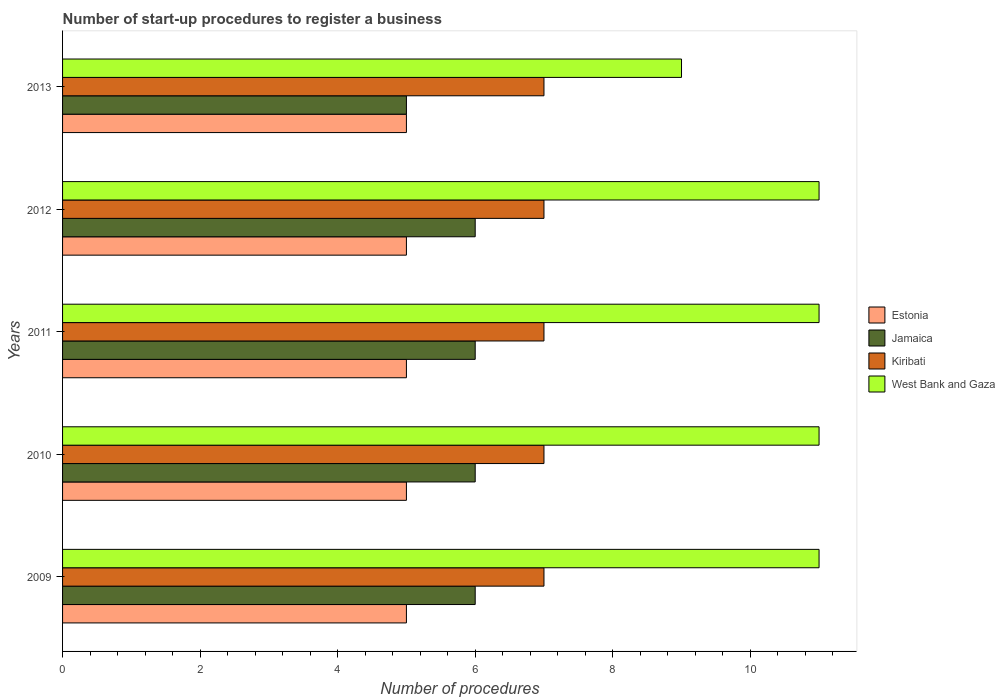How many different coloured bars are there?
Your answer should be compact. 4. How many bars are there on the 5th tick from the top?
Your answer should be very brief. 4. How many bars are there on the 5th tick from the bottom?
Ensure brevity in your answer.  4. What is the number of procedures required to register a business in Kiribati in 2013?
Keep it short and to the point. 7. Across all years, what is the maximum number of procedures required to register a business in Estonia?
Ensure brevity in your answer.  5. Across all years, what is the minimum number of procedures required to register a business in Jamaica?
Ensure brevity in your answer.  5. In which year was the number of procedures required to register a business in West Bank and Gaza maximum?
Your response must be concise. 2009. What is the total number of procedures required to register a business in Kiribati in the graph?
Provide a short and direct response. 35. What is the difference between the number of procedures required to register a business in West Bank and Gaza in 2009 and that in 2013?
Keep it short and to the point. 2. What is the difference between the number of procedures required to register a business in Kiribati in 2010 and the number of procedures required to register a business in West Bank and Gaza in 2012?
Provide a short and direct response. -4. What is the average number of procedures required to register a business in Jamaica per year?
Your answer should be very brief. 5.8. In how many years, is the number of procedures required to register a business in West Bank and Gaza greater than 4 ?
Your answer should be very brief. 5. What is the ratio of the number of procedures required to register a business in Jamaica in 2011 to that in 2012?
Make the answer very short. 1. Is the number of procedures required to register a business in West Bank and Gaza in 2012 less than that in 2013?
Keep it short and to the point. No. Is the difference between the number of procedures required to register a business in Estonia in 2010 and 2011 greater than the difference between the number of procedures required to register a business in Jamaica in 2010 and 2011?
Keep it short and to the point. No. What is the difference between the highest and the second highest number of procedures required to register a business in Jamaica?
Provide a succinct answer. 0. What is the difference between the highest and the lowest number of procedures required to register a business in Estonia?
Keep it short and to the point. 0. In how many years, is the number of procedures required to register a business in Jamaica greater than the average number of procedures required to register a business in Jamaica taken over all years?
Your answer should be very brief. 4. Is the sum of the number of procedures required to register a business in Kiribati in 2010 and 2013 greater than the maximum number of procedures required to register a business in Jamaica across all years?
Provide a short and direct response. Yes. Is it the case that in every year, the sum of the number of procedures required to register a business in Kiribati and number of procedures required to register a business in West Bank and Gaza is greater than the sum of number of procedures required to register a business in Jamaica and number of procedures required to register a business in Estonia?
Keep it short and to the point. Yes. What does the 1st bar from the top in 2010 represents?
Offer a terse response. West Bank and Gaza. What does the 3rd bar from the bottom in 2011 represents?
Keep it short and to the point. Kiribati. Is it the case that in every year, the sum of the number of procedures required to register a business in Jamaica and number of procedures required to register a business in West Bank and Gaza is greater than the number of procedures required to register a business in Estonia?
Offer a terse response. Yes. Are the values on the major ticks of X-axis written in scientific E-notation?
Your answer should be compact. No. Does the graph contain grids?
Give a very brief answer. No. How many legend labels are there?
Your answer should be compact. 4. What is the title of the graph?
Provide a succinct answer. Number of start-up procedures to register a business. Does "Syrian Arab Republic" appear as one of the legend labels in the graph?
Your response must be concise. No. What is the label or title of the X-axis?
Your response must be concise. Number of procedures. What is the Number of procedures of Estonia in 2009?
Your answer should be compact. 5. What is the Number of procedures in Jamaica in 2009?
Ensure brevity in your answer.  6. What is the Number of procedures in Kiribati in 2009?
Give a very brief answer. 7. What is the Number of procedures of Kiribati in 2010?
Provide a short and direct response. 7. What is the Number of procedures of Estonia in 2011?
Your response must be concise. 5. What is the Number of procedures of Kiribati in 2011?
Keep it short and to the point. 7. What is the Number of procedures of West Bank and Gaza in 2011?
Offer a very short reply. 11. What is the Number of procedures of Estonia in 2012?
Your answer should be very brief. 5. What is the Number of procedures of Kiribati in 2012?
Ensure brevity in your answer.  7. What is the Number of procedures in Estonia in 2013?
Provide a succinct answer. 5. What is the Number of procedures in Jamaica in 2013?
Make the answer very short. 5. What is the Number of procedures in West Bank and Gaza in 2013?
Offer a terse response. 9. Across all years, what is the minimum Number of procedures of Jamaica?
Give a very brief answer. 5. What is the total Number of procedures of Estonia in the graph?
Offer a terse response. 25. What is the total Number of procedures in Jamaica in the graph?
Give a very brief answer. 29. What is the total Number of procedures of West Bank and Gaza in the graph?
Keep it short and to the point. 53. What is the difference between the Number of procedures in Estonia in 2009 and that in 2010?
Your answer should be compact. 0. What is the difference between the Number of procedures of Jamaica in 2009 and that in 2010?
Your answer should be very brief. 0. What is the difference between the Number of procedures in West Bank and Gaza in 2009 and that in 2010?
Your answer should be compact. 0. What is the difference between the Number of procedures in West Bank and Gaza in 2009 and that in 2011?
Your answer should be very brief. 0. What is the difference between the Number of procedures of Estonia in 2009 and that in 2012?
Ensure brevity in your answer.  0. What is the difference between the Number of procedures of West Bank and Gaza in 2009 and that in 2012?
Your answer should be compact. 0. What is the difference between the Number of procedures in Estonia in 2009 and that in 2013?
Your answer should be very brief. 0. What is the difference between the Number of procedures of West Bank and Gaza in 2010 and that in 2011?
Offer a very short reply. 0. What is the difference between the Number of procedures of Kiribati in 2010 and that in 2012?
Provide a short and direct response. 0. What is the difference between the Number of procedures in West Bank and Gaza in 2010 and that in 2012?
Your answer should be very brief. 0. What is the difference between the Number of procedures in Jamaica in 2011 and that in 2012?
Give a very brief answer. 0. What is the difference between the Number of procedures in West Bank and Gaza in 2011 and that in 2012?
Your response must be concise. 0. What is the difference between the Number of procedures of Jamaica in 2011 and that in 2013?
Keep it short and to the point. 1. What is the difference between the Number of procedures in Kiribati in 2011 and that in 2013?
Keep it short and to the point. 0. What is the difference between the Number of procedures in Estonia in 2009 and the Number of procedures in Jamaica in 2010?
Give a very brief answer. -1. What is the difference between the Number of procedures of Estonia in 2009 and the Number of procedures of Kiribati in 2011?
Offer a terse response. -2. What is the difference between the Number of procedures of Estonia in 2009 and the Number of procedures of West Bank and Gaza in 2011?
Keep it short and to the point. -6. What is the difference between the Number of procedures of Jamaica in 2009 and the Number of procedures of West Bank and Gaza in 2011?
Offer a terse response. -5. What is the difference between the Number of procedures in Estonia in 2009 and the Number of procedures in Jamaica in 2012?
Your answer should be compact. -1. What is the difference between the Number of procedures in Estonia in 2009 and the Number of procedures in Kiribati in 2012?
Your answer should be compact. -2. What is the difference between the Number of procedures in Estonia in 2009 and the Number of procedures in West Bank and Gaza in 2012?
Give a very brief answer. -6. What is the difference between the Number of procedures in Kiribati in 2009 and the Number of procedures in West Bank and Gaza in 2012?
Provide a succinct answer. -4. What is the difference between the Number of procedures of Estonia in 2009 and the Number of procedures of Jamaica in 2013?
Your answer should be compact. 0. What is the difference between the Number of procedures in Jamaica in 2009 and the Number of procedures in Kiribati in 2013?
Ensure brevity in your answer.  -1. What is the difference between the Number of procedures of Kiribati in 2009 and the Number of procedures of West Bank and Gaza in 2013?
Make the answer very short. -2. What is the difference between the Number of procedures of Estonia in 2010 and the Number of procedures of Jamaica in 2011?
Provide a succinct answer. -1. What is the difference between the Number of procedures in Estonia in 2010 and the Number of procedures in Kiribati in 2011?
Offer a very short reply. -2. What is the difference between the Number of procedures in Estonia in 2010 and the Number of procedures in West Bank and Gaza in 2011?
Your answer should be very brief. -6. What is the difference between the Number of procedures in Jamaica in 2010 and the Number of procedures in Kiribati in 2011?
Make the answer very short. -1. What is the difference between the Number of procedures in Kiribati in 2010 and the Number of procedures in West Bank and Gaza in 2011?
Provide a succinct answer. -4. What is the difference between the Number of procedures in Estonia in 2010 and the Number of procedures in West Bank and Gaza in 2012?
Your answer should be compact. -6. What is the difference between the Number of procedures of Jamaica in 2010 and the Number of procedures of Kiribati in 2012?
Offer a terse response. -1. What is the difference between the Number of procedures in Estonia in 2010 and the Number of procedures in Jamaica in 2013?
Give a very brief answer. 0. What is the difference between the Number of procedures of Estonia in 2011 and the Number of procedures of Jamaica in 2012?
Offer a very short reply. -1. What is the difference between the Number of procedures in Estonia in 2011 and the Number of procedures in West Bank and Gaza in 2012?
Offer a terse response. -6. What is the difference between the Number of procedures in Kiribati in 2011 and the Number of procedures in West Bank and Gaza in 2012?
Your answer should be very brief. -4. What is the difference between the Number of procedures of Estonia in 2011 and the Number of procedures of Jamaica in 2013?
Provide a short and direct response. 0. What is the difference between the Number of procedures of Estonia in 2011 and the Number of procedures of West Bank and Gaza in 2013?
Your answer should be very brief. -4. What is the difference between the Number of procedures in Jamaica in 2011 and the Number of procedures in Kiribati in 2013?
Your answer should be very brief. -1. What is the difference between the Number of procedures in Estonia in 2012 and the Number of procedures in Jamaica in 2013?
Your response must be concise. 0. What is the difference between the Number of procedures of Estonia in 2012 and the Number of procedures of Kiribati in 2013?
Your answer should be compact. -2. What is the difference between the Number of procedures in Estonia in 2012 and the Number of procedures in West Bank and Gaza in 2013?
Provide a short and direct response. -4. What is the difference between the Number of procedures in Jamaica in 2012 and the Number of procedures in Kiribati in 2013?
Provide a succinct answer. -1. What is the difference between the Number of procedures of Jamaica in 2012 and the Number of procedures of West Bank and Gaza in 2013?
Provide a short and direct response. -3. What is the difference between the Number of procedures in Kiribati in 2012 and the Number of procedures in West Bank and Gaza in 2013?
Ensure brevity in your answer.  -2. What is the average Number of procedures of Jamaica per year?
Give a very brief answer. 5.8. What is the average Number of procedures in Kiribati per year?
Your answer should be compact. 7. In the year 2010, what is the difference between the Number of procedures in Estonia and Number of procedures in Jamaica?
Provide a short and direct response. -1. In the year 2010, what is the difference between the Number of procedures in Estonia and Number of procedures in Kiribati?
Your answer should be compact. -2. In the year 2010, what is the difference between the Number of procedures in Estonia and Number of procedures in West Bank and Gaza?
Provide a short and direct response. -6. In the year 2010, what is the difference between the Number of procedures of Jamaica and Number of procedures of West Bank and Gaza?
Your answer should be very brief. -5. In the year 2011, what is the difference between the Number of procedures of Estonia and Number of procedures of Jamaica?
Provide a short and direct response. -1. In the year 2011, what is the difference between the Number of procedures of Estonia and Number of procedures of Kiribati?
Your answer should be compact. -2. In the year 2011, what is the difference between the Number of procedures in Estonia and Number of procedures in West Bank and Gaza?
Provide a succinct answer. -6. In the year 2012, what is the difference between the Number of procedures of Estonia and Number of procedures of Kiribati?
Give a very brief answer. -2. In the year 2012, what is the difference between the Number of procedures of Estonia and Number of procedures of West Bank and Gaza?
Provide a short and direct response. -6. In the year 2012, what is the difference between the Number of procedures in Jamaica and Number of procedures in West Bank and Gaza?
Give a very brief answer. -5. In the year 2013, what is the difference between the Number of procedures of Estonia and Number of procedures of Kiribati?
Give a very brief answer. -2. In the year 2013, what is the difference between the Number of procedures of Estonia and Number of procedures of West Bank and Gaza?
Offer a terse response. -4. In the year 2013, what is the difference between the Number of procedures in Jamaica and Number of procedures in Kiribati?
Make the answer very short. -2. In the year 2013, what is the difference between the Number of procedures in Jamaica and Number of procedures in West Bank and Gaza?
Keep it short and to the point. -4. In the year 2013, what is the difference between the Number of procedures of Kiribati and Number of procedures of West Bank and Gaza?
Provide a succinct answer. -2. What is the ratio of the Number of procedures of Estonia in 2009 to that in 2010?
Provide a succinct answer. 1. What is the ratio of the Number of procedures in West Bank and Gaza in 2009 to that in 2010?
Offer a terse response. 1. What is the ratio of the Number of procedures in Jamaica in 2009 to that in 2011?
Your answer should be compact. 1. What is the ratio of the Number of procedures in West Bank and Gaza in 2009 to that in 2011?
Provide a short and direct response. 1. What is the ratio of the Number of procedures of Jamaica in 2009 to that in 2012?
Provide a short and direct response. 1. What is the ratio of the Number of procedures of Kiribati in 2009 to that in 2013?
Provide a succinct answer. 1. What is the ratio of the Number of procedures of West Bank and Gaza in 2009 to that in 2013?
Keep it short and to the point. 1.22. What is the ratio of the Number of procedures of Kiribati in 2010 to that in 2011?
Keep it short and to the point. 1. What is the ratio of the Number of procedures of West Bank and Gaza in 2010 to that in 2011?
Ensure brevity in your answer.  1. What is the ratio of the Number of procedures of Estonia in 2010 to that in 2012?
Your response must be concise. 1. What is the ratio of the Number of procedures of Jamaica in 2010 to that in 2012?
Your response must be concise. 1. What is the ratio of the Number of procedures in Kiribati in 2010 to that in 2012?
Your answer should be very brief. 1. What is the ratio of the Number of procedures in Jamaica in 2010 to that in 2013?
Give a very brief answer. 1.2. What is the ratio of the Number of procedures in Kiribati in 2010 to that in 2013?
Give a very brief answer. 1. What is the ratio of the Number of procedures in West Bank and Gaza in 2010 to that in 2013?
Offer a terse response. 1.22. What is the ratio of the Number of procedures of Estonia in 2011 to that in 2012?
Ensure brevity in your answer.  1. What is the ratio of the Number of procedures of Kiribati in 2011 to that in 2012?
Provide a succinct answer. 1. What is the ratio of the Number of procedures of West Bank and Gaza in 2011 to that in 2012?
Provide a succinct answer. 1. What is the ratio of the Number of procedures of Jamaica in 2011 to that in 2013?
Give a very brief answer. 1.2. What is the ratio of the Number of procedures in Kiribati in 2011 to that in 2013?
Give a very brief answer. 1. What is the ratio of the Number of procedures in West Bank and Gaza in 2011 to that in 2013?
Give a very brief answer. 1.22. What is the ratio of the Number of procedures of West Bank and Gaza in 2012 to that in 2013?
Provide a succinct answer. 1.22. What is the difference between the highest and the second highest Number of procedures in Estonia?
Ensure brevity in your answer.  0. What is the difference between the highest and the second highest Number of procedures of Jamaica?
Make the answer very short. 0. What is the difference between the highest and the second highest Number of procedures of Kiribati?
Keep it short and to the point. 0. 